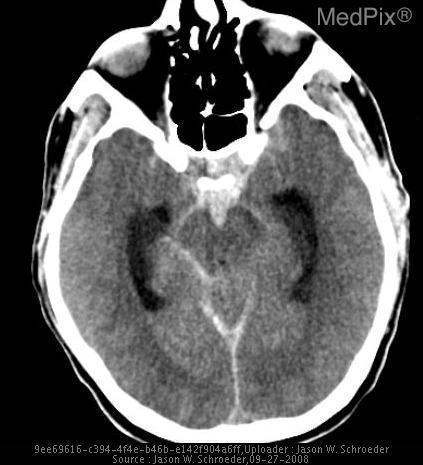Is there a blood clot?
Write a very short answer. Yes. Where is the bleed?
Give a very brief answer. Subarachnoid. What kind of brain bleed is this?
Give a very brief answer. Subarachnoid. Do you see dependent layering in the occipital horns of the lateral ventricles?
Keep it brief. Yes. Is there dependent layering in the occipital horns of the lateral ventricles?
Concise answer only. Yes. Any evidence of epidural or subdural hematoma?
Give a very brief answer. No. Are there epidural or subdural bleeds as well?
Concise answer only. No. 